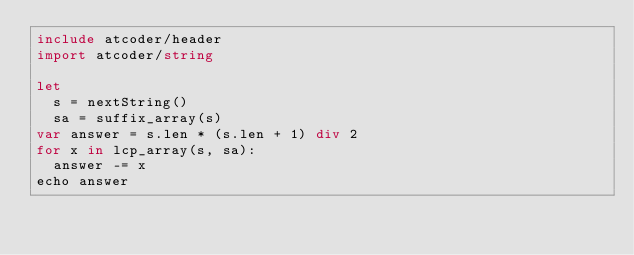Convert code to text. <code><loc_0><loc_0><loc_500><loc_500><_Nim_>include atcoder/header
import atcoder/string

let
  s = nextString()
  sa = suffix_array(s)
var answer = s.len * (s.len + 1) div 2
for x in lcp_array(s, sa):
  answer -= x
echo answer
</code> 